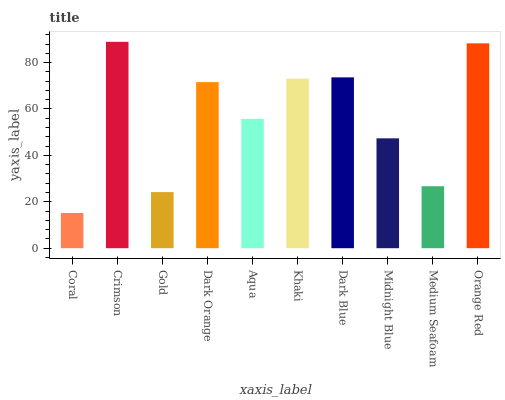Is Coral the minimum?
Answer yes or no. Yes. Is Crimson the maximum?
Answer yes or no. Yes. Is Gold the minimum?
Answer yes or no. No. Is Gold the maximum?
Answer yes or no. No. Is Crimson greater than Gold?
Answer yes or no. Yes. Is Gold less than Crimson?
Answer yes or no. Yes. Is Gold greater than Crimson?
Answer yes or no. No. Is Crimson less than Gold?
Answer yes or no. No. Is Dark Orange the high median?
Answer yes or no. Yes. Is Aqua the low median?
Answer yes or no. Yes. Is Dark Blue the high median?
Answer yes or no. No. Is Khaki the low median?
Answer yes or no. No. 